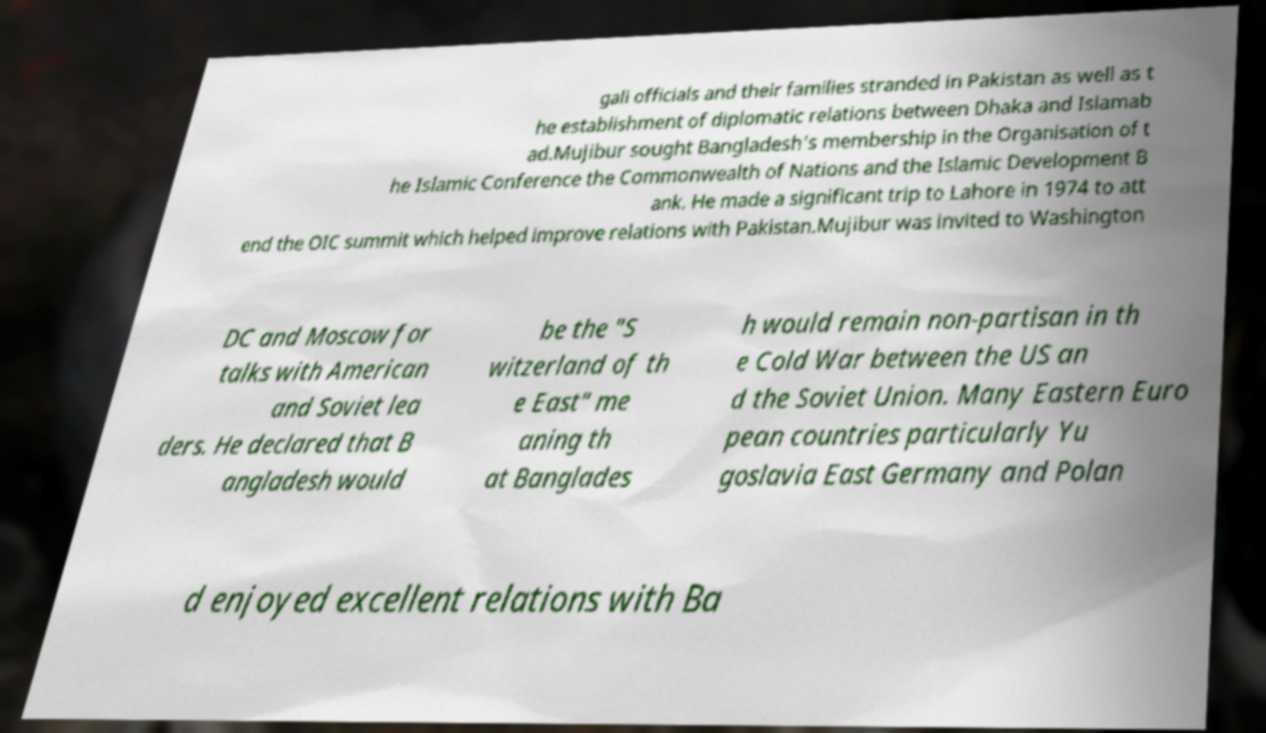Please read and relay the text visible in this image. What does it say? gali officials and their families stranded in Pakistan as well as t he establishment of diplomatic relations between Dhaka and Islamab ad.Mujibur sought Bangladesh's membership in the Organisation of t he Islamic Conference the Commonwealth of Nations and the Islamic Development B ank. He made a significant trip to Lahore in 1974 to att end the OIC summit which helped improve relations with Pakistan.Mujibur was invited to Washington DC and Moscow for talks with American and Soviet lea ders. He declared that B angladesh would be the "S witzerland of th e East" me aning th at Banglades h would remain non-partisan in th e Cold War between the US an d the Soviet Union. Many Eastern Euro pean countries particularly Yu goslavia East Germany and Polan d enjoyed excellent relations with Ba 